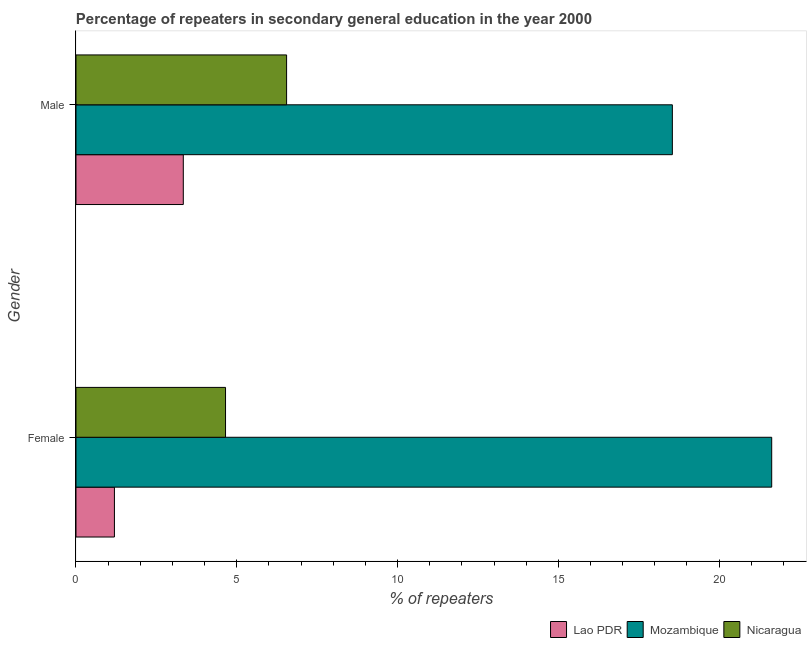How many different coloured bars are there?
Your answer should be compact. 3. How many bars are there on the 2nd tick from the bottom?
Provide a succinct answer. 3. What is the label of the 1st group of bars from the top?
Make the answer very short. Male. What is the percentage of female repeaters in Lao PDR?
Give a very brief answer. 1.2. Across all countries, what is the maximum percentage of female repeaters?
Offer a terse response. 21.63. Across all countries, what is the minimum percentage of male repeaters?
Give a very brief answer. 3.34. In which country was the percentage of female repeaters maximum?
Ensure brevity in your answer.  Mozambique. In which country was the percentage of female repeaters minimum?
Ensure brevity in your answer.  Lao PDR. What is the total percentage of male repeaters in the graph?
Your answer should be compact. 28.43. What is the difference between the percentage of female repeaters in Nicaragua and that in Lao PDR?
Your answer should be compact. 3.46. What is the difference between the percentage of male repeaters in Lao PDR and the percentage of female repeaters in Mozambique?
Provide a succinct answer. -18.3. What is the average percentage of female repeaters per country?
Make the answer very short. 9.16. What is the difference between the percentage of female repeaters and percentage of male repeaters in Nicaragua?
Your answer should be very brief. -1.9. What is the ratio of the percentage of male repeaters in Nicaragua to that in Lao PDR?
Your response must be concise. 1.96. Is the percentage of male repeaters in Lao PDR less than that in Nicaragua?
Make the answer very short. Yes. In how many countries, is the percentage of male repeaters greater than the average percentage of male repeaters taken over all countries?
Ensure brevity in your answer.  1. What does the 1st bar from the top in Male represents?
Provide a succinct answer. Nicaragua. What does the 1st bar from the bottom in Female represents?
Give a very brief answer. Lao PDR. Are all the bars in the graph horizontal?
Provide a succinct answer. Yes. What is the difference between two consecutive major ticks on the X-axis?
Offer a terse response. 5. Are the values on the major ticks of X-axis written in scientific E-notation?
Provide a short and direct response. No. How are the legend labels stacked?
Provide a succinct answer. Horizontal. What is the title of the graph?
Your response must be concise. Percentage of repeaters in secondary general education in the year 2000. What is the label or title of the X-axis?
Your answer should be very brief. % of repeaters. What is the label or title of the Y-axis?
Keep it short and to the point. Gender. What is the % of repeaters in Lao PDR in Female?
Offer a very short reply. 1.2. What is the % of repeaters of Mozambique in Female?
Provide a short and direct response. 21.63. What is the % of repeaters of Nicaragua in Female?
Your answer should be very brief. 4.65. What is the % of repeaters in Lao PDR in Male?
Provide a succinct answer. 3.34. What is the % of repeaters in Mozambique in Male?
Keep it short and to the point. 18.55. What is the % of repeaters of Nicaragua in Male?
Ensure brevity in your answer.  6.55. Across all Gender, what is the maximum % of repeaters of Lao PDR?
Provide a short and direct response. 3.34. Across all Gender, what is the maximum % of repeaters of Mozambique?
Offer a terse response. 21.63. Across all Gender, what is the maximum % of repeaters of Nicaragua?
Provide a succinct answer. 6.55. Across all Gender, what is the minimum % of repeaters in Lao PDR?
Ensure brevity in your answer.  1.2. Across all Gender, what is the minimum % of repeaters of Mozambique?
Offer a terse response. 18.55. Across all Gender, what is the minimum % of repeaters of Nicaragua?
Offer a terse response. 4.65. What is the total % of repeaters of Lao PDR in the graph?
Provide a short and direct response. 4.53. What is the total % of repeaters of Mozambique in the graph?
Offer a very short reply. 40.18. What is the total % of repeaters in Nicaragua in the graph?
Provide a succinct answer. 11.2. What is the difference between the % of repeaters in Lao PDR in Female and that in Male?
Offer a very short reply. -2.14. What is the difference between the % of repeaters in Mozambique in Female and that in Male?
Make the answer very short. 3.09. What is the difference between the % of repeaters of Nicaragua in Female and that in Male?
Your answer should be compact. -1.9. What is the difference between the % of repeaters in Lao PDR in Female and the % of repeaters in Mozambique in Male?
Ensure brevity in your answer.  -17.35. What is the difference between the % of repeaters in Lao PDR in Female and the % of repeaters in Nicaragua in Male?
Keep it short and to the point. -5.35. What is the difference between the % of repeaters in Mozambique in Female and the % of repeaters in Nicaragua in Male?
Your response must be concise. 15.09. What is the average % of repeaters in Lao PDR per Gender?
Keep it short and to the point. 2.27. What is the average % of repeaters of Mozambique per Gender?
Your answer should be very brief. 20.09. What is the average % of repeaters in Nicaragua per Gender?
Keep it short and to the point. 5.6. What is the difference between the % of repeaters of Lao PDR and % of repeaters of Mozambique in Female?
Your answer should be very brief. -20.44. What is the difference between the % of repeaters of Lao PDR and % of repeaters of Nicaragua in Female?
Give a very brief answer. -3.46. What is the difference between the % of repeaters in Mozambique and % of repeaters in Nicaragua in Female?
Your response must be concise. 16.98. What is the difference between the % of repeaters of Lao PDR and % of repeaters of Mozambique in Male?
Provide a short and direct response. -15.21. What is the difference between the % of repeaters of Lao PDR and % of repeaters of Nicaragua in Male?
Your response must be concise. -3.21. What is the difference between the % of repeaters of Mozambique and % of repeaters of Nicaragua in Male?
Provide a short and direct response. 12. What is the ratio of the % of repeaters in Lao PDR in Female to that in Male?
Make the answer very short. 0.36. What is the ratio of the % of repeaters in Mozambique in Female to that in Male?
Give a very brief answer. 1.17. What is the ratio of the % of repeaters in Nicaragua in Female to that in Male?
Provide a succinct answer. 0.71. What is the difference between the highest and the second highest % of repeaters in Lao PDR?
Keep it short and to the point. 2.14. What is the difference between the highest and the second highest % of repeaters of Mozambique?
Offer a very short reply. 3.09. What is the difference between the highest and the second highest % of repeaters of Nicaragua?
Provide a short and direct response. 1.9. What is the difference between the highest and the lowest % of repeaters in Lao PDR?
Make the answer very short. 2.14. What is the difference between the highest and the lowest % of repeaters in Mozambique?
Provide a short and direct response. 3.09. What is the difference between the highest and the lowest % of repeaters of Nicaragua?
Provide a short and direct response. 1.9. 